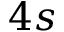Convert formula to latex. <formula><loc_0><loc_0><loc_500><loc_500>4 s</formula> 